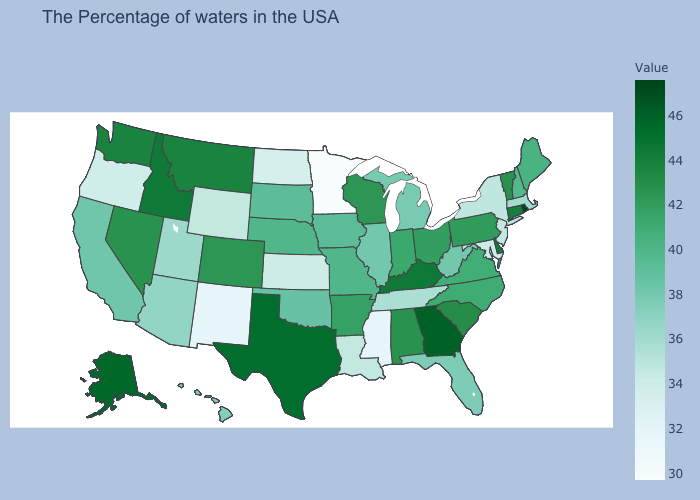Which states have the lowest value in the USA?
Write a very short answer. Minnesota. Which states hav the highest value in the Northeast?
Write a very short answer. Rhode Island. Which states have the highest value in the USA?
Quick response, please. Rhode Island. Which states have the lowest value in the MidWest?
Keep it brief. Minnesota. Does Michigan have the highest value in the USA?
Quick response, please. No. Does Minnesota have a higher value than Mississippi?
Keep it brief. No. Does Alaska have a higher value than Oregon?
Give a very brief answer. Yes. 